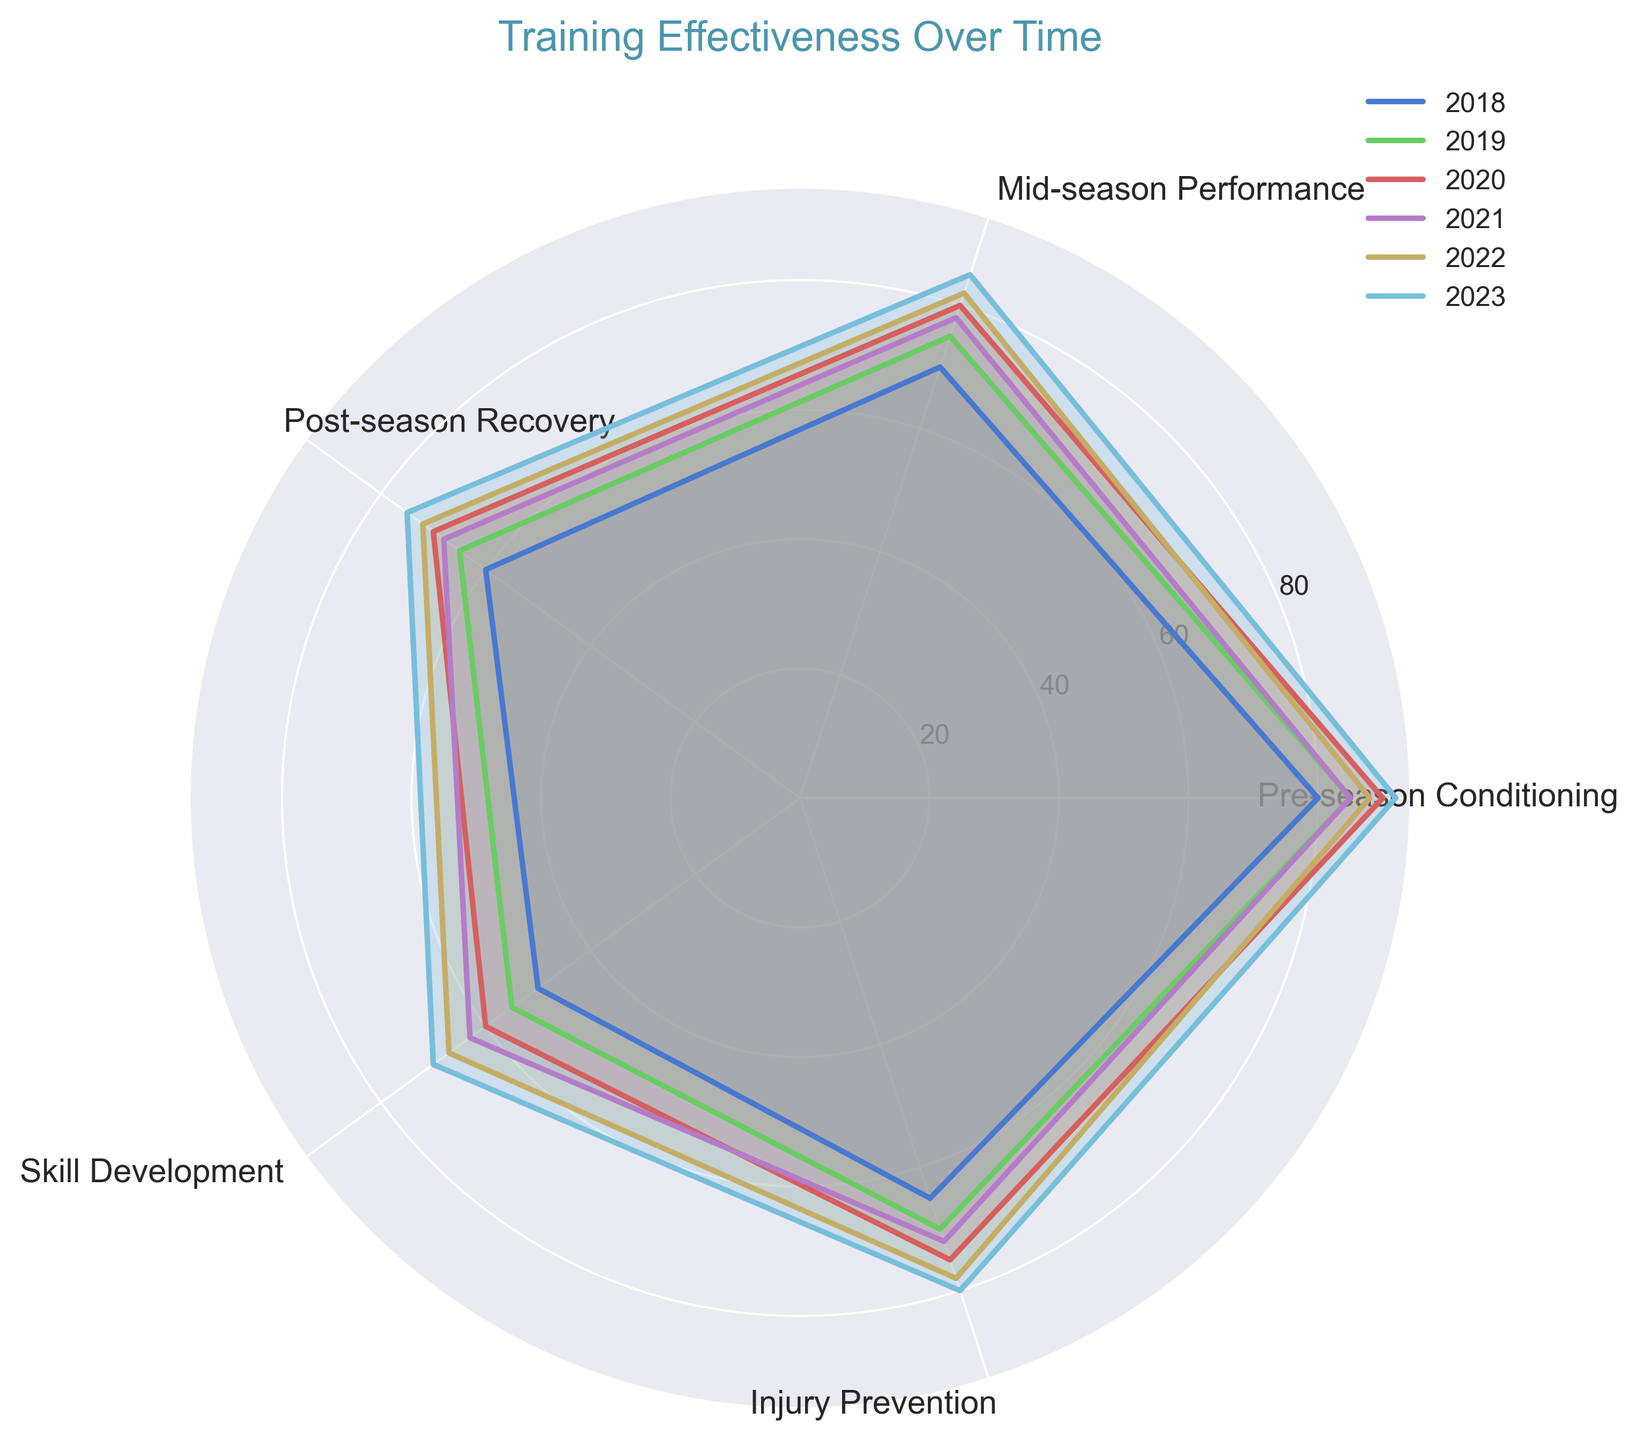Which period had the highest Mid-season Performance? By reviewing the radar chart, we can see that each period is labeled by year, and we can identify which period has the highest point along the 'Mid-season Performance' axis. The highest point on this axis corresponds to 2023.
Answer: 2023 How did Injury Prevention change from 2018 to 2023? By visually comparing the points on the 'Injury Prevention' axis for 2018 and 2023, we can see the progression. The values increase from 65 in 2018 to 80 in 2023.
Answer: Increased Which period shows the lowest Skill Development? By examining the points along the 'Skill Development' axis for each period, we identify that 2018 has the lowest point, indicating a value of 50.
Answer: 2018 What is the average Pre-season Conditioning value across all periods? To find the average, sum the Pre-season Conditioning values for all periods (80+85+90+85+88+92=520) and divide by the number of periods (6). \(520 \div 6 = 86.67\).
Answer: 86.67 Compare the Post-season Recovery between 2020 and 2021. On the 'Post-season Recovery' axis, note the values for 2020 (70) and 2021 (68). Comparing these two values, 2020 has a slightly higher recovery value than 2021.
Answer: 2020 is higher Which period had the most balanced performance across all categories? By observing the plotted lines and filled areas for each period, the most balanced performance would appear as the one with the least variability (most even shape). 2023 appears to be the most balanced across all dimensions.
Answer: 2023 How much did the average value of Skill Development increase from 2018 to 2023? First, calculate the individual values: 2018 is 50 and 2023 is 70. The difference is 70 - 50 = 20. Then, to find the average increase per year over 5 years (2023 - 2018), divide the increase by the number of years. \(20 \div 5 = 4\).
Answer: 4 Which category had the largest improvement from 2018 to 2023? By comparing each category's values in 2018 and 2023, calculate the difference: Pre-season Conditioning (92-80=12), Mid-season Performance (85-70=15), Post-season Recovery (75-60=15), Skill Development (70-50=20), Injury Prevention (80-65=15). Skill Development shows the largest improvement of 20 units.
Answer: Skill Development 